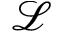<formula> <loc_0><loc_0><loc_500><loc_500>\mathcal { L }</formula> 